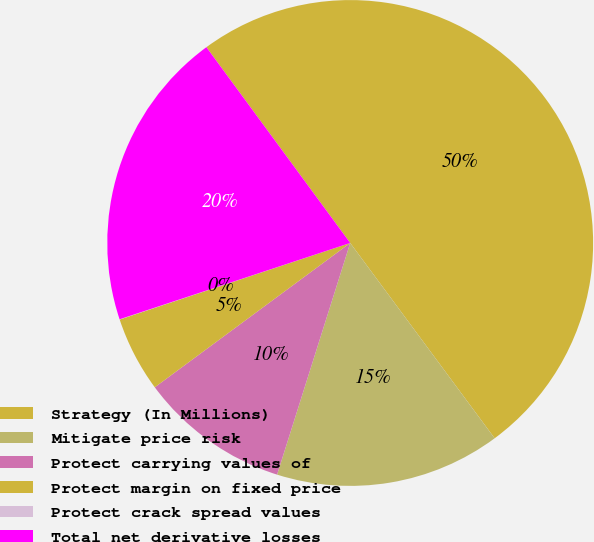<chart> <loc_0><loc_0><loc_500><loc_500><pie_chart><fcel>Strategy (In Millions)<fcel>Mitigate price risk<fcel>Protect carrying values of<fcel>Protect margin on fixed price<fcel>Protect crack spread values<fcel>Total net derivative losses<nl><fcel>49.95%<fcel>15.0%<fcel>10.01%<fcel>5.02%<fcel>0.02%<fcel>20.0%<nl></chart> 